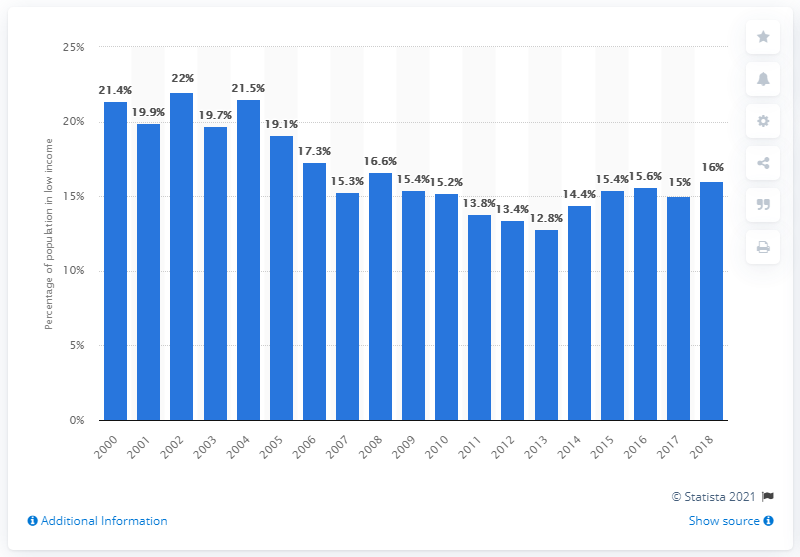Indicate a few pertinent items in this graphic. In 2018, it was estimated that approximately 16% of the population of Newfoundland and Labrador was considered to be living in low income. 